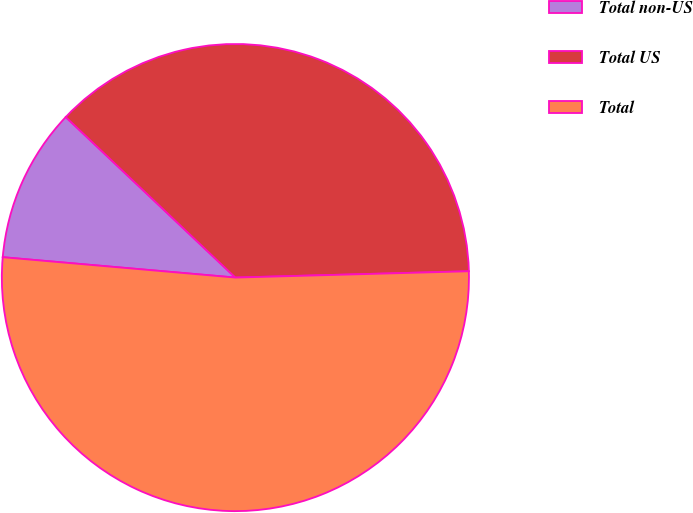<chart> <loc_0><loc_0><loc_500><loc_500><pie_chart><fcel>Total non-US<fcel>Total US<fcel>Total<nl><fcel>10.67%<fcel>37.51%<fcel>51.82%<nl></chart> 